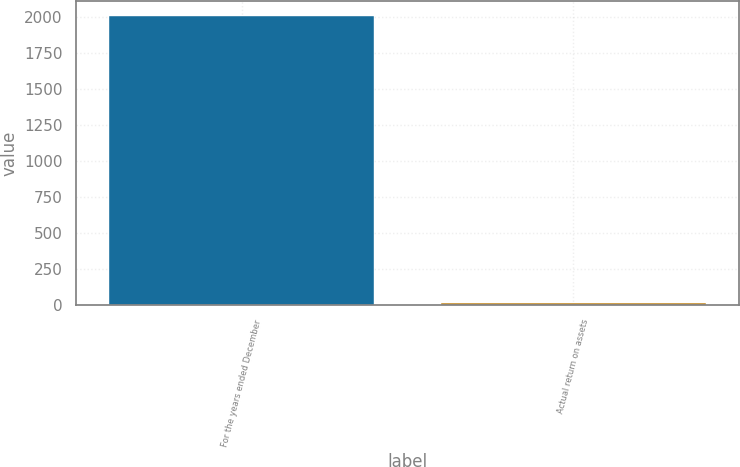<chart> <loc_0><loc_0><loc_500><loc_500><bar_chart><fcel>For the years ended December<fcel>Actual return on assets<nl><fcel>2010<fcel>13.3<nl></chart> 